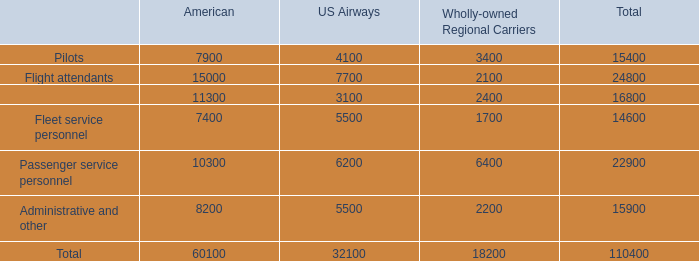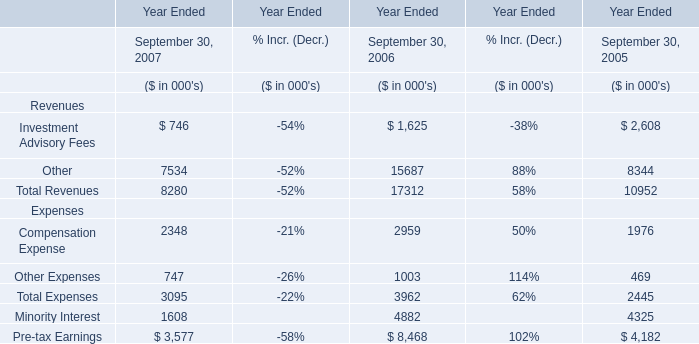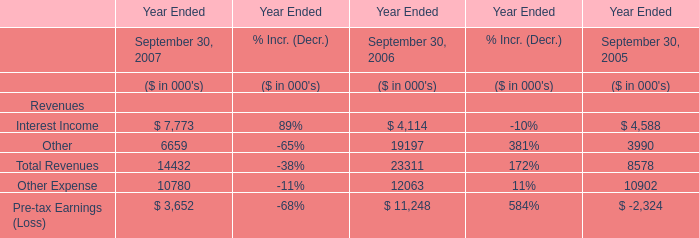In what year is total revenue greater than 20000? 
Answer: 2006. 